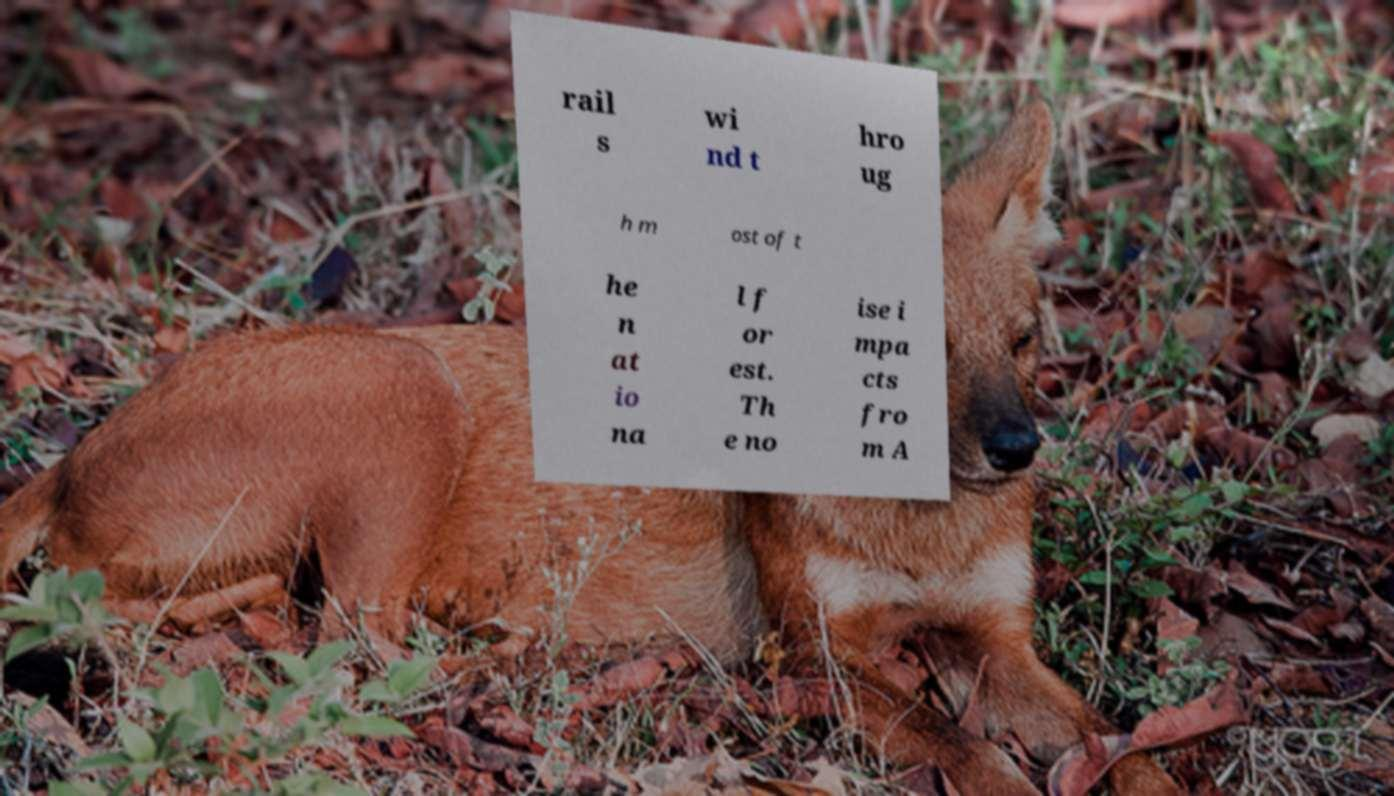Can you read and provide the text displayed in the image?This photo seems to have some interesting text. Can you extract and type it out for me? rail s wi nd t hro ug h m ost of t he n at io na l f or est. Th e no ise i mpa cts fro m A 